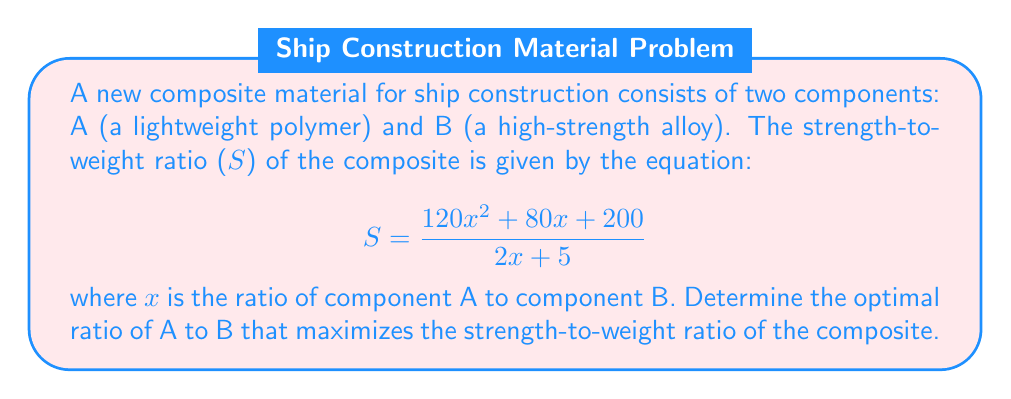Give your solution to this math problem. To find the optimal ratio, we need to maximize the function S(x). We can do this by finding the critical points of the function and evaluating them.

Step 1: Calculate the derivative of S(x) using the quotient rule.
$$S'(x) = \frac{(2x + 5)(240x + 80) - (120x^2 + 80x + 200)(2)}{(2x + 5)^2}$$

Step 2: Simplify the numerator of S'(x).
$$S'(x) = \frac{480x^2 + 1200x + 400 - 240x^2 - 160x - 400}{(2x + 5)^2}$$
$$S'(x) = \frac{240x^2 + 1040x}{(2x + 5)^2}$$

Step 3: Set S'(x) = 0 and solve for x.
$$\frac{240x^2 + 1040x}{(2x + 5)^2} = 0$$
$$240x^2 + 1040x = 0$$
$$240x(x + \frac{13}{3}) = 0$$

Step 4: Solve the equation.
$x = 0$ or $x = -\frac{13}{3}$

Since x represents a ratio of materials, it cannot be negative. Therefore, x = 0 is not a valid solution.

Step 5: Check the endpoints of the domain.
As x approaches infinity, S(x) approaches 60.
As x approaches -5/2 (from the right), S(x) approaches negative infinity.

Step 6: Evaluate S(x) at x = 13/3.
$$S(\frac{13}{3}) = \frac{120(\frac{13}{3})^2 + 80(\frac{13}{3}) + 200}{2(\frac{13}{3}) + 5} = \frac{2860}{13} \approx 220$$

Therefore, the maximum strength-to-weight ratio occurs when the ratio of component A to component B is 13:3.
Answer: 13:3 